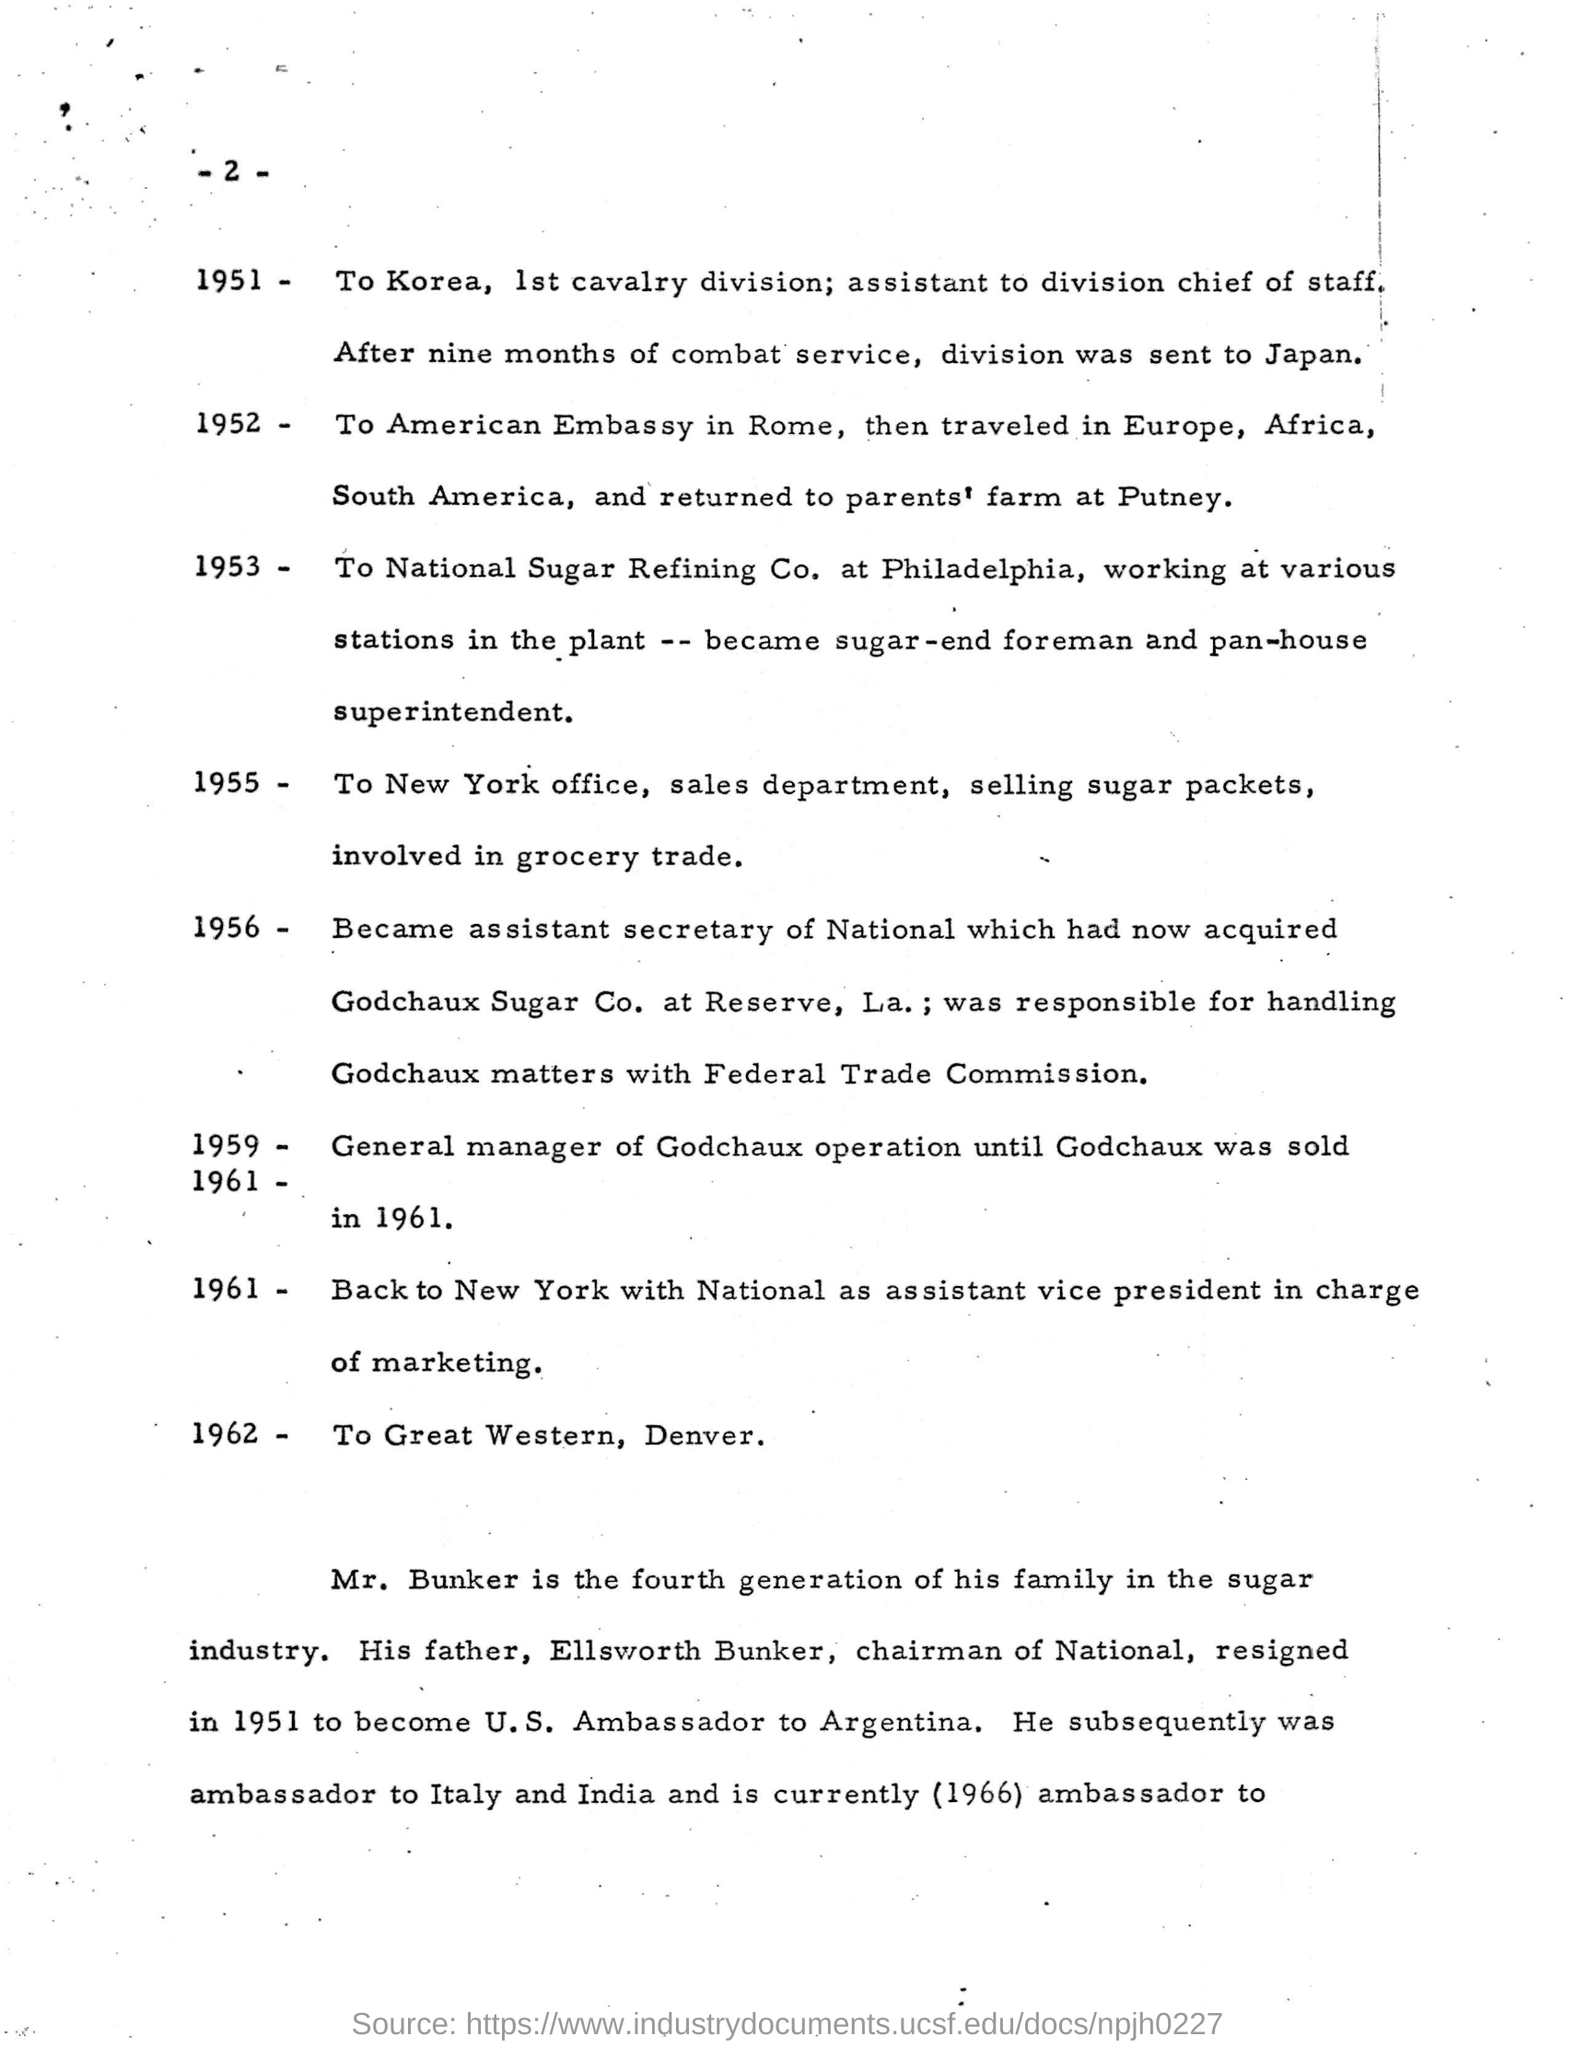Give some essential details in this illustration. Ellsworth Bunker is the father of Mr. Bunker. The New York office of the Sales Department was mentioned in 1955. The division will be sent to Japan nine months after. Mr. Bunker belongs to the fourth generation of his family. 